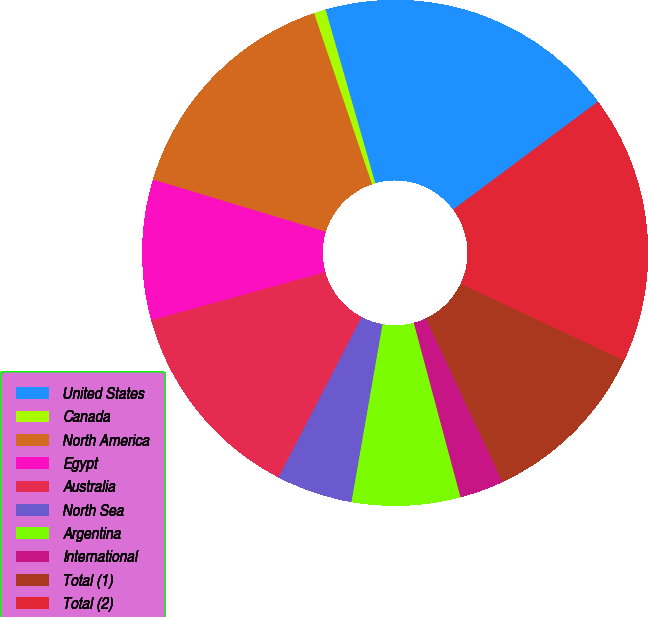Convert chart to OTSL. <chart><loc_0><loc_0><loc_500><loc_500><pie_chart><fcel>United States<fcel>Canada<fcel>North America<fcel>Egypt<fcel>Australia<fcel>North Sea<fcel>Argentina<fcel>International<fcel>Total (1)<fcel>Total (2)<nl><fcel>19.24%<fcel>0.76%<fcel>15.13%<fcel>8.97%<fcel>13.08%<fcel>4.87%<fcel>6.92%<fcel>2.81%<fcel>11.03%<fcel>17.19%<nl></chart> 